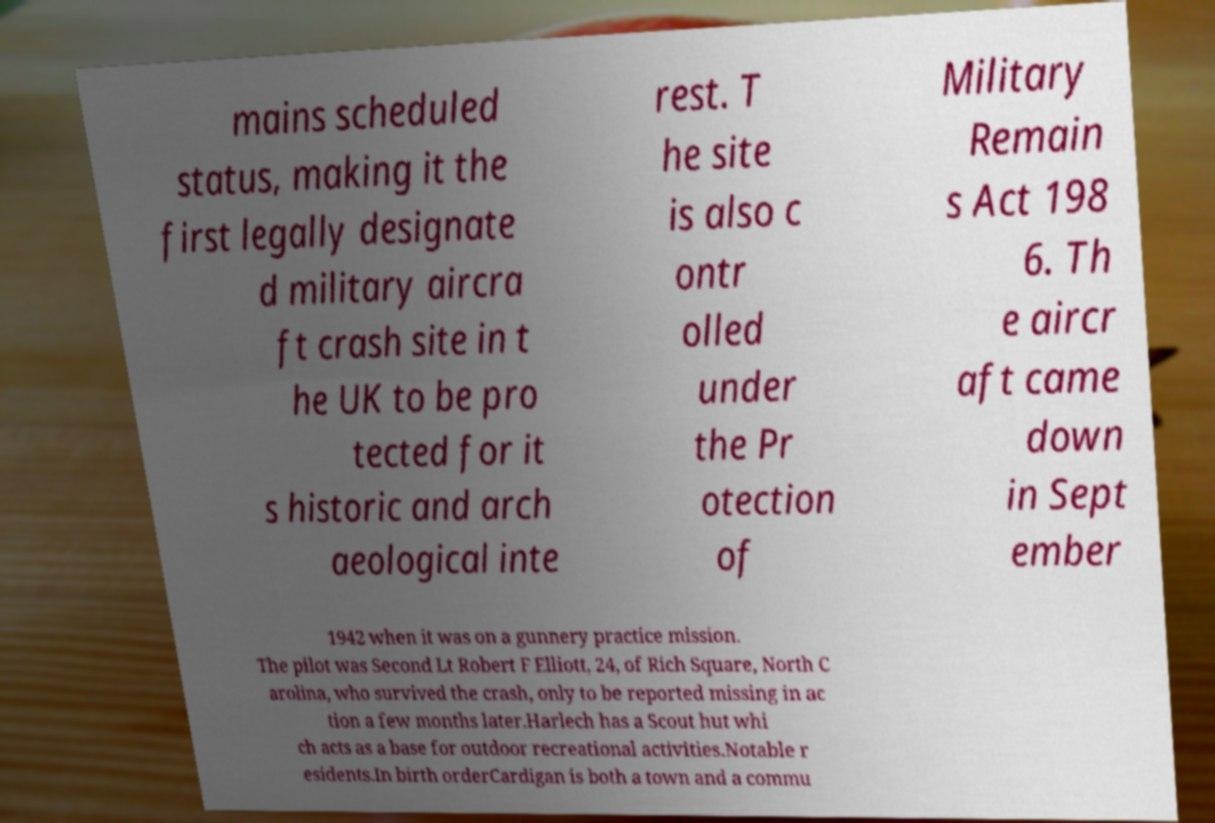For documentation purposes, I need the text within this image transcribed. Could you provide that? mains scheduled status, making it the first legally designate d military aircra ft crash site in t he UK to be pro tected for it s historic and arch aeological inte rest. T he site is also c ontr olled under the Pr otection of Military Remain s Act 198 6. Th e aircr aft came down in Sept ember 1942 when it was on a gunnery practice mission. The pilot was Second Lt Robert F Elliott, 24, of Rich Square, North C arolina, who survived the crash, only to be reported missing in ac tion a few months later.Harlech has a Scout hut whi ch acts as a base for outdoor recreational activities.Notable r esidents.In birth orderCardigan is both a town and a commu 